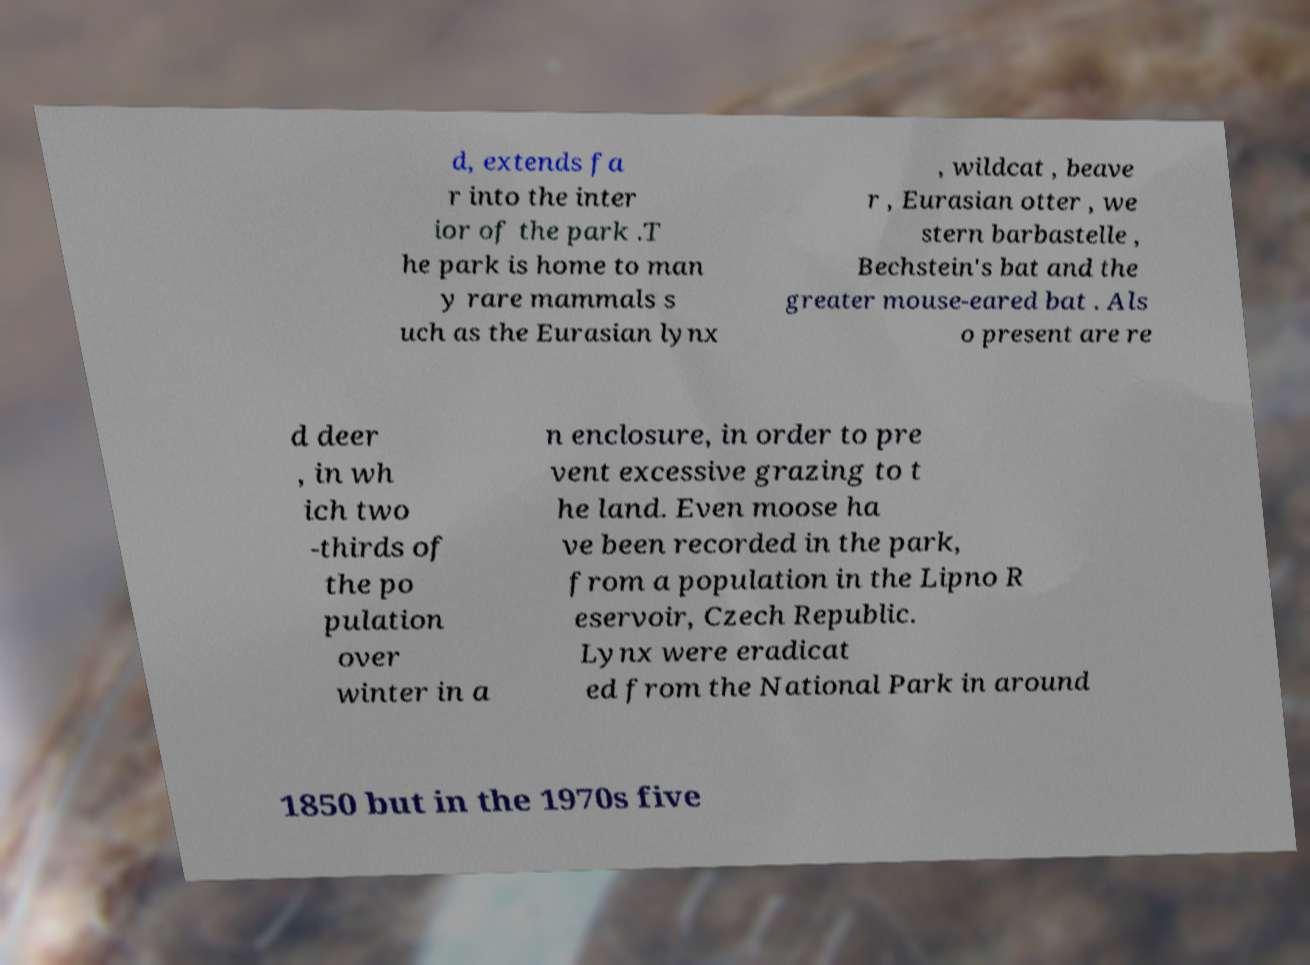Could you assist in decoding the text presented in this image and type it out clearly? d, extends fa r into the inter ior of the park .T he park is home to man y rare mammals s uch as the Eurasian lynx , wildcat , beave r , Eurasian otter , we stern barbastelle , Bechstein's bat and the greater mouse-eared bat . Als o present are re d deer , in wh ich two -thirds of the po pulation over winter in a n enclosure, in order to pre vent excessive grazing to t he land. Even moose ha ve been recorded in the park, from a population in the Lipno R eservoir, Czech Republic. Lynx were eradicat ed from the National Park in around 1850 but in the 1970s five 